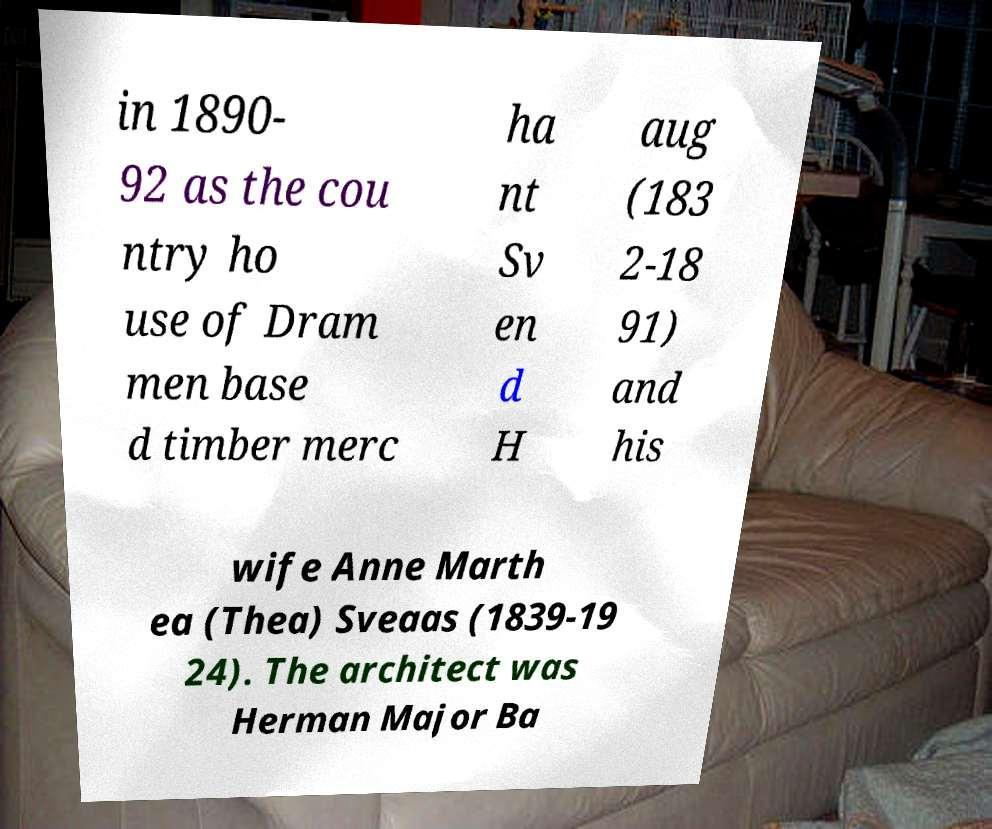What messages or text are displayed in this image? I need them in a readable, typed format. in 1890- 92 as the cou ntry ho use of Dram men base d timber merc ha nt Sv en d H aug (183 2-18 91) and his wife Anne Marth ea (Thea) Sveaas (1839-19 24). The architect was Herman Major Ba 